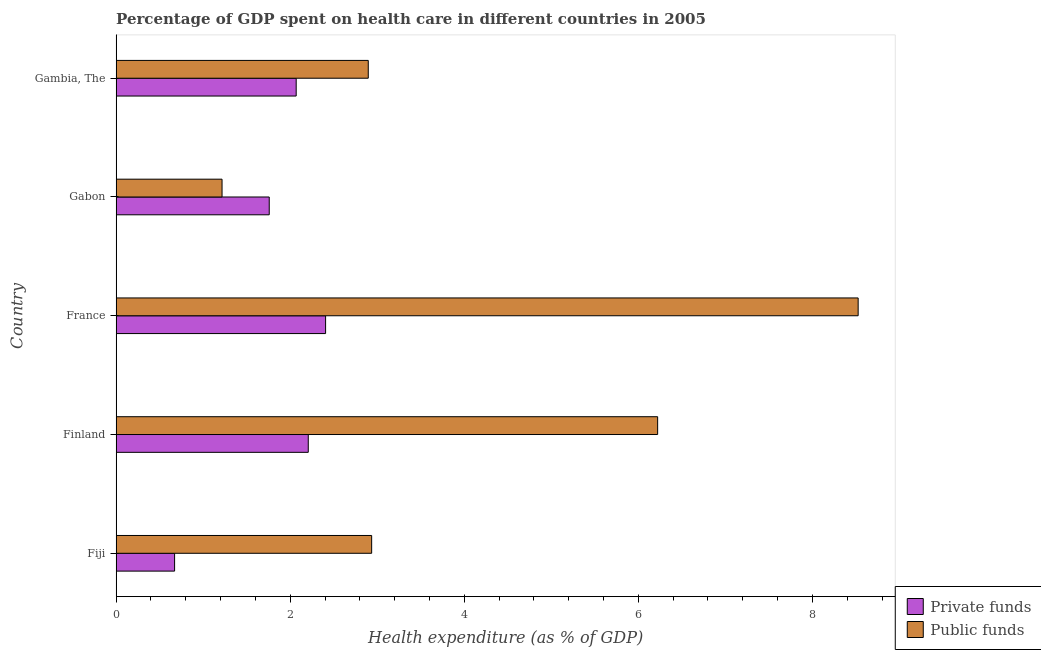Are the number of bars per tick equal to the number of legend labels?
Offer a terse response. Yes. What is the label of the 3rd group of bars from the top?
Your answer should be very brief. France. In how many cases, is the number of bars for a given country not equal to the number of legend labels?
Provide a short and direct response. 0. What is the amount of private funds spent in healthcare in Fiji?
Give a very brief answer. 0.67. Across all countries, what is the maximum amount of public funds spent in healthcare?
Make the answer very short. 8.53. Across all countries, what is the minimum amount of private funds spent in healthcare?
Offer a terse response. 0.67. In which country was the amount of public funds spent in healthcare minimum?
Offer a very short reply. Gabon. What is the total amount of private funds spent in healthcare in the graph?
Your response must be concise. 9.11. What is the difference between the amount of public funds spent in healthcare in Finland and that in Gabon?
Your answer should be compact. 5. What is the difference between the amount of private funds spent in healthcare in Fiji and the amount of public funds spent in healthcare in Finland?
Keep it short and to the point. -5.55. What is the average amount of private funds spent in healthcare per country?
Make the answer very short. 1.82. What is the difference between the amount of public funds spent in healthcare and amount of private funds spent in healthcare in Finland?
Offer a terse response. 4.01. In how many countries, is the amount of private funds spent in healthcare greater than 7.6 %?
Provide a short and direct response. 0. What is the ratio of the amount of private funds spent in healthcare in Fiji to that in France?
Give a very brief answer. 0.28. Is the amount of private funds spent in healthcare in Fiji less than that in Gambia, The?
Offer a very short reply. Yes. What is the difference between the highest and the second highest amount of private funds spent in healthcare?
Offer a very short reply. 0.2. What is the difference between the highest and the lowest amount of private funds spent in healthcare?
Offer a terse response. 1.74. Is the sum of the amount of private funds spent in healthcare in France and Gabon greater than the maximum amount of public funds spent in healthcare across all countries?
Your answer should be compact. No. What does the 2nd bar from the top in France represents?
Offer a terse response. Private funds. What does the 1st bar from the bottom in Gabon represents?
Provide a succinct answer. Private funds. What is the difference between two consecutive major ticks on the X-axis?
Make the answer very short. 2. Are the values on the major ticks of X-axis written in scientific E-notation?
Ensure brevity in your answer.  No. Does the graph contain grids?
Provide a short and direct response. No. Where does the legend appear in the graph?
Provide a short and direct response. Bottom right. How many legend labels are there?
Ensure brevity in your answer.  2. What is the title of the graph?
Ensure brevity in your answer.  Percentage of GDP spent on health care in different countries in 2005. What is the label or title of the X-axis?
Your answer should be compact. Health expenditure (as % of GDP). What is the Health expenditure (as % of GDP) of Private funds in Fiji?
Your answer should be compact. 0.67. What is the Health expenditure (as % of GDP) of Public funds in Fiji?
Your response must be concise. 2.94. What is the Health expenditure (as % of GDP) of Private funds in Finland?
Your response must be concise. 2.21. What is the Health expenditure (as % of GDP) of Public funds in Finland?
Your answer should be compact. 6.22. What is the Health expenditure (as % of GDP) in Private funds in France?
Offer a very short reply. 2.41. What is the Health expenditure (as % of GDP) of Public funds in France?
Give a very brief answer. 8.53. What is the Health expenditure (as % of GDP) in Private funds in Gabon?
Your response must be concise. 1.76. What is the Health expenditure (as % of GDP) in Public funds in Gabon?
Keep it short and to the point. 1.22. What is the Health expenditure (as % of GDP) of Private funds in Gambia, The?
Provide a short and direct response. 2.07. What is the Health expenditure (as % of GDP) in Public funds in Gambia, The?
Keep it short and to the point. 2.9. Across all countries, what is the maximum Health expenditure (as % of GDP) in Private funds?
Give a very brief answer. 2.41. Across all countries, what is the maximum Health expenditure (as % of GDP) in Public funds?
Offer a very short reply. 8.53. Across all countries, what is the minimum Health expenditure (as % of GDP) in Private funds?
Your answer should be very brief. 0.67. Across all countries, what is the minimum Health expenditure (as % of GDP) of Public funds?
Give a very brief answer. 1.22. What is the total Health expenditure (as % of GDP) in Private funds in the graph?
Make the answer very short. 9.11. What is the total Health expenditure (as % of GDP) of Public funds in the graph?
Provide a succinct answer. 21.8. What is the difference between the Health expenditure (as % of GDP) in Private funds in Fiji and that in Finland?
Give a very brief answer. -1.54. What is the difference between the Health expenditure (as % of GDP) of Public funds in Fiji and that in Finland?
Provide a succinct answer. -3.29. What is the difference between the Health expenditure (as % of GDP) of Private funds in Fiji and that in France?
Give a very brief answer. -1.74. What is the difference between the Health expenditure (as % of GDP) in Public funds in Fiji and that in France?
Your response must be concise. -5.59. What is the difference between the Health expenditure (as % of GDP) of Private funds in Fiji and that in Gabon?
Offer a terse response. -1.09. What is the difference between the Health expenditure (as % of GDP) of Public funds in Fiji and that in Gabon?
Give a very brief answer. 1.72. What is the difference between the Health expenditure (as % of GDP) in Private funds in Fiji and that in Gambia, The?
Your answer should be compact. -1.4. What is the difference between the Health expenditure (as % of GDP) of Public funds in Fiji and that in Gambia, The?
Give a very brief answer. 0.04. What is the difference between the Health expenditure (as % of GDP) in Private funds in Finland and that in France?
Ensure brevity in your answer.  -0.2. What is the difference between the Health expenditure (as % of GDP) of Public funds in Finland and that in France?
Keep it short and to the point. -2.3. What is the difference between the Health expenditure (as % of GDP) in Private funds in Finland and that in Gabon?
Keep it short and to the point. 0.45. What is the difference between the Health expenditure (as % of GDP) in Public funds in Finland and that in Gabon?
Your answer should be very brief. 5. What is the difference between the Health expenditure (as % of GDP) in Private funds in Finland and that in Gambia, The?
Give a very brief answer. 0.14. What is the difference between the Health expenditure (as % of GDP) of Public funds in Finland and that in Gambia, The?
Make the answer very short. 3.32. What is the difference between the Health expenditure (as % of GDP) of Private funds in France and that in Gabon?
Your answer should be very brief. 0.65. What is the difference between the Health expenditure (as % of GDP) in Public funds in France and that in Gabon?
Offer a very short reply. 7.31. What is the difference between the Health expenditure (as % of GDP) of Private funds in France and that in Gambia, The?
Ensure brevity in your answer.  0.34. What is the difference between the Health expenditure (as % of GDP) of Public funds in France and that in Gambia, The?
Your answer should be compact. 5.63. What is the difference between the Health expenditure (as % of GDP) in Private funds in Gabon and that in Gambia, The?
Your response must be concise. -0.31. What is the difference between the Health expenditure (as % of GDP) of Public funds in Gabon and that in Gambia, The?
Give a very brief answer. -1.68. What is the difference between the Health expenditure (as % of GDP) of Private funds in Fiji and the Health expenditure (as % of GDP) of Public funds in Finland?
Keep it short and to the point. -5.55. What is the difference between the Health expenditure (as % of GDP) of Private funds in Fiji and the Health expenditure (as % of GDP) of Public funds in France?
Your answer should be very brief. -7.85. What is the difference between the Health expenditure (as % of GDP) of Private funds in Fiji and the Health expenditure (as % of GDP) of Public funds in Gabon?
Your answer should be very brief. -0.55. What is the difference between the Health expenditure (as % of GDP) of Private funds in Fiji and the Health expenditure (as % of GDP) of Public funds in Gambia, The?
Your response must be concise. -2.23. What is the difference between the Health expenditure (as % of GDP) in Private funds in Finland and the Health expenditure (as % of GDP) in Public funds in France?
Your response must be concise. -6.32. What is the difference between the Health expenditure (as % of GDP) of Private funds in Finland and the Health expenditure (as % of GDP) of Public funds in Gabon?
Make the answer very short. 0.99. What is the difference between the Health expenditure (as % of GDP) of Private funds in Finland and the Health expenditure (as % of GDP) of Public funds in Gambia, The?
Provide a short and direct response. -0.69. What is the difference between the Health expenditure (as % of GDP) in Private funds in France and the Health expenditure (as % of GDP) in Public funds in Gabon?
Your answer should be very brief. 1.19. What is the difference between the Health expenditure (as % of GDP) in Private funds in France and the Health expenditure (as % of GDP) in Public funds in Gambia, The?
Give a very brief answer. -0.49. What is the difference between the Health expenditure (as % of GDP) in Private funds in Gabon and the Health expenditure (as % of GDP) in Public funds in Gambia, The?
Your response must be concise. -1.14. What is the average Health expenditure (as % of GDP) in Private funds per country?
Make the answer very short. 1.82. What is the average Health expenditure (as % of GDP) of Public funds per country?
Give a very brief answer. 4.36. What is the difference between the Health expenditure (as % of GDP) of Private funds and Health expenditure (as % of GDP) of Public funds in Fiji?
Offer a terse response. -2.26. What is the difference between the Health expenditure (as % of GDP) of Private funds and Health expenditure (as % of GDP) of Public funds in Finland?
Provide a short and direct response. -4.01. What is the difference between the Health expenditure (as % of GDP) of Private funds and Health expenditure (as % of GDP) of Public funds in France?
Your answer should be very brief. -6.12. What is the difference between the Health expenditure (as % of GDP) in Private funds and Health expenditure (as % of GDP) in Public funds in Gabon?
Your answer should be very brief. 0.54. What is the difference between the Health expenditure (as % of GDP) in Private funds and Health expenditure (as % of GDP) in Public funds in Gambia, The?
Your answer should be compact. -0.83. What is the ratio of the Health expenditure (as % of GDP) in Private funds in Fiji to that in Finland?
Provide a short and direct response. 0.3. What is the ratio of the Health expenditure (as % of GDP) of Public funds in Fiji to that in Finland?
Your answer should be very brief. 0.47. What is the ratio of the Health expenditure (as % of GDP) in Private funds in Fiji to that in France?
Your response must be concise. 0.28. What is the ratio of the Health expenditure (as % of GDP) of Public funds in Fiji to that in France?
Ensure brevity in your answer.  0.34. What is the ratio of the Health expenditure (as % of GDP) of Private funds in Fiji to that in Gabon?
Offer a very short reply. 0.38. What is the ratio of the Health expenditure (as % of GDP) of Public funds in Fiji to that in Gabon?
Your answer should be very brief. 2.41. What is the ratio of the Health expenditure (as % of GDP) of Private funds in Fiji to that in Gambia, The?
Keep it short and to the point. 0.32. What is the ratio of the Health expenditure (as % of GDP) of Public funds in Fiji to that in Gambia, The?
Provide a succinct answer. 1.01. What is the ratio of the Health expenditure (as % of GDP) of Private funds in Finland to that in France?
Offer a very short reply. 0.92. What is the ratio of the Health expenditure (as % of GDP) of Public funds in Finland to that in France?
Your answer should be compact. 0.73. What is the ratio of the Health expenditure (as % of GDP) of Private funds in Finland to that in Gabon?
Your answer should be compact. 1.25. What is the ratio of the Health expenditure (as % of GDP) in Public funds in Finland to that in Gabon?
Make the answer very short. 5.11. What is the ratio of the Health expenditure (as % of GDP) in Private funds in Finland to that in Gambia, The?
Make the answer very short. 1.07. What is the ratio of the Health expenditure (as % of GDP) of Public funds in Finland to that in Gambia, The?
Ensure brevity in your answer.  2.15. What is the ratio of the Health expenditure (as % of GDP) of Private funds in France to that in Gabon?
Provide a succinct answer. 1.37. What is the ratio of the Health expenditure (as % of GDP) of Public funds in France to that in Gabon?
Your answer should be very brief. 7.01. What is the ratio of the Health expenditure (as % of GDP) in Private funds in France to that in Gambia, The?
Ensure brevity in your answer.  1.16. What is the ratio of the Health expenditure (as % of GDP) in Public funds in France to that in Gambia, The?
Provide a short and direct response. 2.94. What is the ratio of the Health expenditure (as % of GDP) of Private funds in Gabon to that in Gambia, The?
Give a very brief answer. 0.85. What is the ratio of the Health expenditure (as % of GDP) in Public funds in Gabon to that in Gambia, The?
Make the answer very short. 0.42. What is the difference between the highest and the second highest Health expenditure (as % of GDP) in Private funds?
Your answer should be very brief. 0.2. What is the difference between the highest and the second highest Health expenditure (as % of GDP) of Public funds?
Keep it short and to the point. 2.3. What is the difference between the highest and the lowest Health expenditure (as % of GDP) in Private funds?
Ensure brevity in your answer.  1.74. What is the difference between the highest and the lowest Health expenditure (as % of GDP) in Public funds?
Your answer should be very brief. 7.31. 